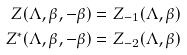Convert formula to latex. <formula><loc_0><loc_0><loc_500><loc_500>Z ( \Lambda , \beta , - \beta ) & = Z _ { - 1 } ( \Lambda , \beta ) \\ Z ^ { * } ( \Lambda , \beta , - \beta ) & = Z _ { - 2 } ( \Lambda , \beta )</formula> 